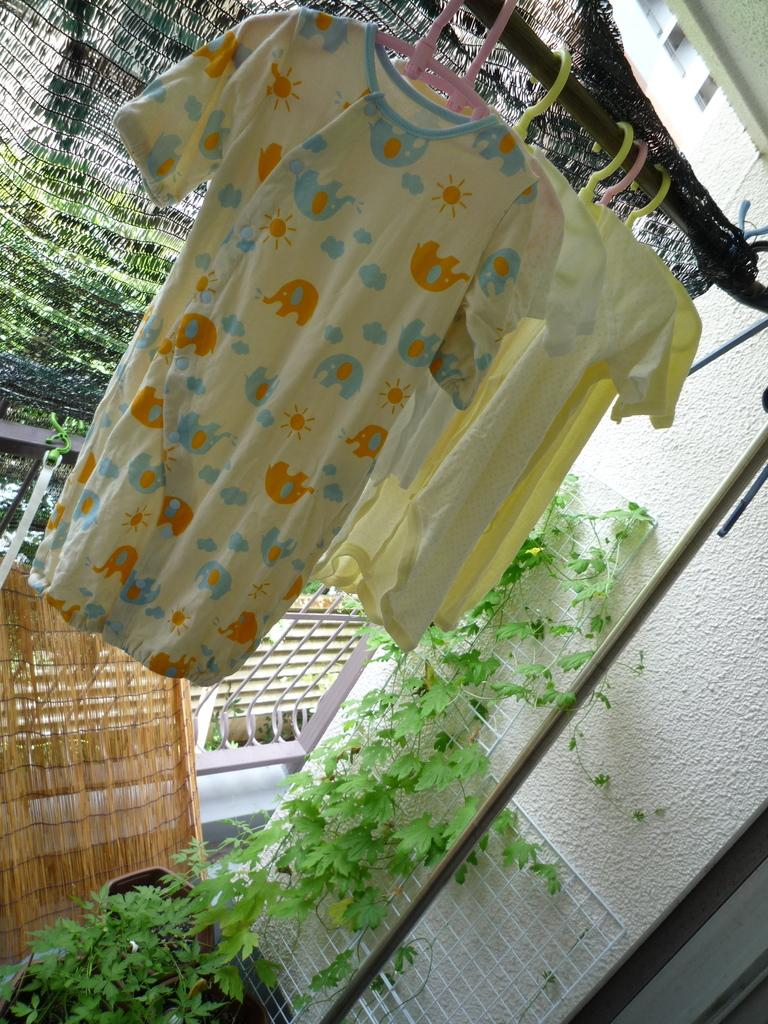What is hanging on the rod in the image? There are clothes hanging on a rod in the image. What celestial bodies can be seen in the image? There are planets visible in the image. What type of cooking appliance is present in the image? There is a grill in the image. What is one of the structural elements in the image? There is a wall in the image. How many snails can be seen crawling on the grill in the image? There are no snails present in the image; it features clothes hanging on a rod, planets, a grill, and a wall. What type of sea creature is swimming near the clothes hanging on the rod in the image? There are no sea creatures, such as jellyfish, present in the image. 